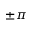<formula> <loc_0><loc_0><loc_500><loc_500>\pm \pi</formula> 